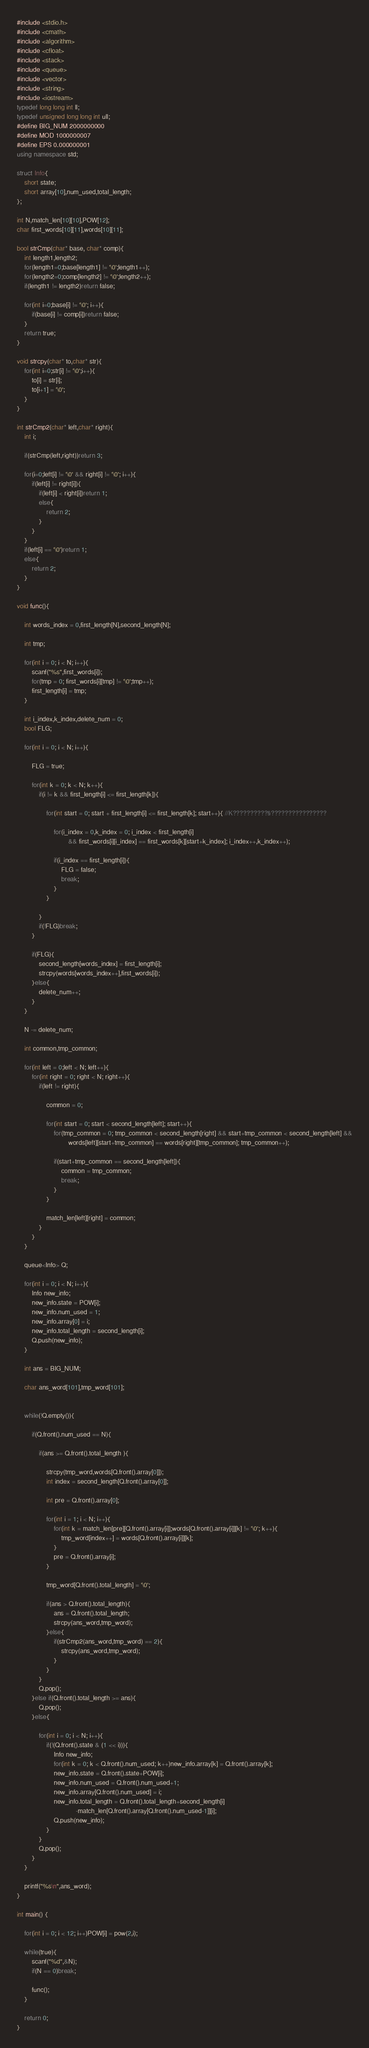Convert code to text. <code><loc_0><loc_0><loc_500><loc_500><_C++_>#include <stdio.h>
#include <cmath>
#include <algorithm>
#include <cfloat>
#include <stack>
#include <queue>
#include <vector>
#include <string>
#include <iostream>
typedef long long int ll;
typedef unsigned long long int ull;
#define BIG_NUM 2000000000
#define MOD 1000000007
#define EPS 0.000000001
using namespace std;

struct Info{
	short state;
	short array[10],num_used,total_length;
};

int N,match_len[10][10],POW[12];
char first_words[10][11],words[10][11];

bool strCmp(char* base, char* comp){
	int length1,length2;
	for(length1=0;base[length1] != '\0';length1++);
	for(length2=0;comp[length2] != '\0';length2++);
	if(length1 != length2)return false;

	for(int i=0;base[i] != '\0'; i++){
		if(base[i] != comp[i])return false;
	}
	return true;
}

void strcpy(char* to,char* str){
	for(int i=0;str[i] != '\0';i++){
		to[i] = str[i];
		to[i+1] = '\0';
	}
}

int strCmp2(char* left,char* right){
	int i;

	if(strCmp(left,right))return 3;

	for(i=0;left[i] != '\0' && right[i] != '\0'; i++){
		if(left[i] != right[i]){
			if(left[i] < right[i])return 1;
			else{
				return 2;
			}
		}
	}
	if(left[i] == '\0')return 1;
	else{
		return 2;
	}
}

void func(){

	int words_index = 0,first_length[N],second_length[N];

	int tmp;

	for(int i = 0; i < N; i++){
		scanf("%s",first_words[i]);
		for(tmp = 0; first_words[i][tmp] != '\0';tmp++);
		first_length[i] = tmp;
	}

	int i_index,k_index,delete_num = 0;
	bool FLG;

	for(int i = 0; i < N; i++){

		FLG = true;

		for(int k = 0; k < N; k++){
			if(i != k && first_length[i] <= first_length[k]){

				for(int start = 0; start + first_length[i] <= first_length[k]; start++){ //K??????????§????????????????

					for(i_index = 0,k_index = 0; i_index < first_length[i]
							&& first_words[i][i_index] == first_words[k][start+k_index]; i_index++,k_index++);

					if(i_index == first_length[i]){
						FLG = false;
						break;
					}
				}

			}
			if(!FLG)break;
		}

		if(FLG){
			second_length[words_index] = first_length[i];
			strcpy(words[words_index++],first_words[i]);
		}else{
			delete_num++;
		}
	}

	N -= delete_num;

	int common,tmp_common;

	for(int left = 0;left < N; left++){
		for(int right = 0; right < N; right++){
			if(left != right){

				common = 0;

				for(int start = 0; start < second_length[left]; start++){
					for(tmp_common = 0; tmp_common < second_length[right] && start+tmp_common < second_length[left] &&
							words[left][start+tmp_common] == words[right][tmp_common]; tmp_common++);

					if(start+tmp_common == second_length[left]){
						common = tmp_common;
						break;
					}
				}

				match_len[left][right] = common;
			}
		}
	}

	queue<Info> Q;

	for(int i = 0; i < N; i++){
		Info new_info;
		new_info.state = POW[i];
		new_info.num_used = 1;
		new_info.array[0] = i;
		new_info.total_length = second_length[i];
		Q.push(new_info);
	}

	int ans = BIG_NUM;

	char ans_word[101],tmp_word[101];


	while(!Q.empty()){

		if(Q.front().num_used == N){

			if(ans >= Q.front().total_length ){

				strcpy(tmp_word,words[Q.front().array[0]]);
				int index = second_length[Q.front().array[0]];

				int pre = Q.front().array[0];

				for(int i = 1; i < N; i++){
					for(int k = match_len[pre][Q.front().array[i]];words[Q.front().array[i]][k] != '\0'; k++){
						tmp_word[index++] = words[Q.front().array[i]][k];
					}
					pre = Q.front().array[i];
				}

				tmp_word[Q.front().total_length] = '\0';

				if(ans > Q.front().total_length){
					ans = Q.front().total_length;
					strcpy(ans_word,tmp_word);
				}else{
					if(strCmp2(ans_word,tmp_word) == 2){
						strcpy(ans_word,tmp_word);
					}
				}
			}
			Q.pop();
		}else if(Q.front().total_length >= ans){
			Q.pop();
		}else{

			for(int i = 0; i < N; i++){
				if(!(Q.front().state & (1 << i))){
					Info new_info;
					for(int k = 0; k < Q.front().num_used; k++)new_info.array[k] = Q.front().array[k];
					new_info.state = Q.front().state+POW[i];
					new_info.num_used = Q.front().num_used+1;
					new_info.array[Q.front().num_used] = i;
					new_info.total_length = Q.front().total_length+second_length[i]
								-match_len[Q.front().array[Q.front().num_used-1]][i];
					Q.push(new_info);
				}
			}
			Q.pop();
		}
	}

	printf("%s\n",ans_word);
}

int main() {

	for(int i = 0; i < 12; i++)POW[i] = pow(2,i);

	while(true){
		scanf("%d",&N);
		if(N == 0)break;

		func();
	}

	return 0;
}</code> 